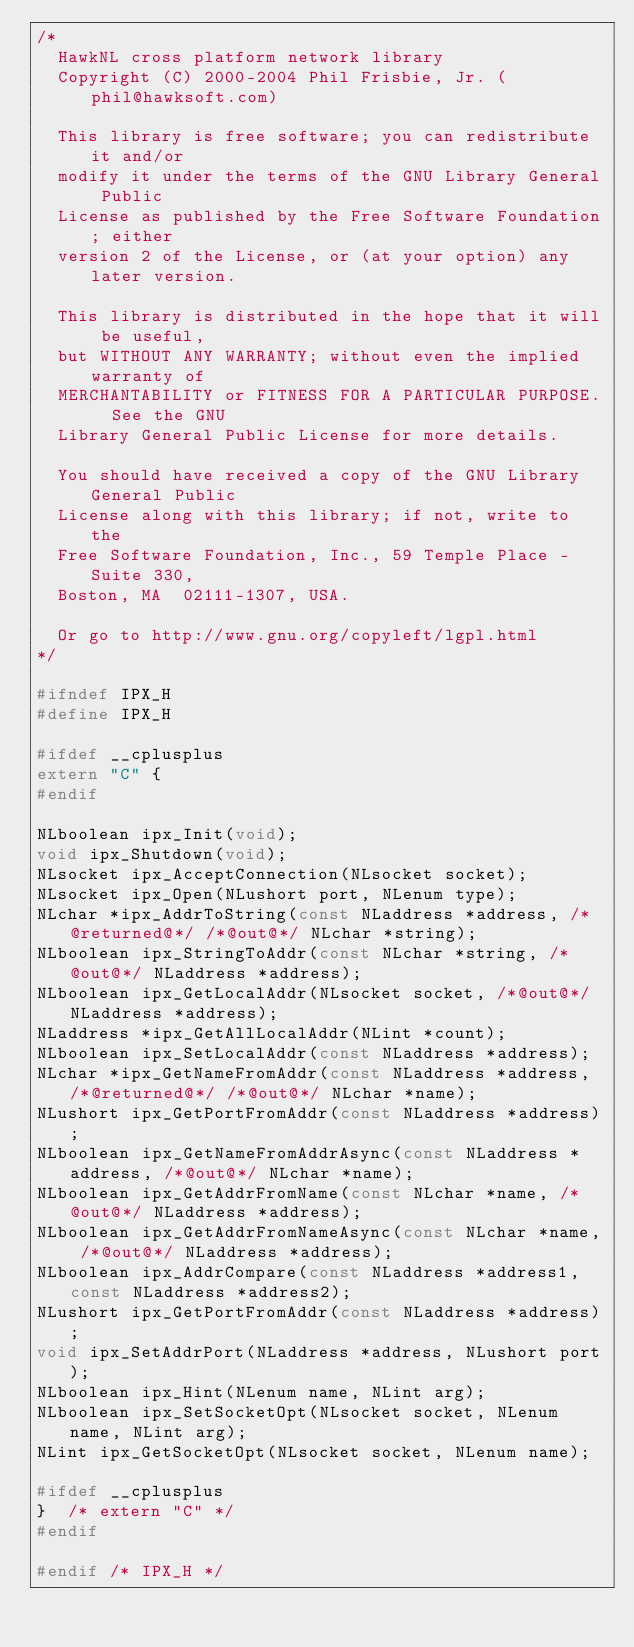Convert code to text. <code><loc_0><loc_0><loc_500><loc_500><_C_>/*
  HawkNL cross platform network library
  Copyright (C) 2000-2004 Phil Frisbie, Jr. (phil@hawksoft.com)

  This library is free software; you can redistribute it and/or
  modify it under the terms of the GNU Library General Public
  License as published by the Free Software Foundation; either
  version 2 of the License, or (at your option) any later version.

  This library is distributed in the hope that it will be useful,
  but WITHOUT ANY WARRANTY; without even the implied warranty of
  MERCHANTABILITY or FITNESS FOR A PARTICULAR PURPOSE.  See the GNU
  Library General Public License for more details.

  You should have received a copy of the GNU Library General Public
  License along with this library; if not, write to the
  Free Software Foundation, Inc., 59 Temple Place - Suite 330,
  Boston, MA  02111-1307, USA.

  Or go to http://www.gnu.org/copyleft/lgpl.html
*/

#ifndef IPX_H
#define IPX_H

#ifdef __cplusplus
extern "C" {
#endif

NLboolean ipx_Init(void);
void ipx_Shutdown(void);
NLsocket ipx_AcceptConnection(NLsocket socket);
NLsocket ipx_Open(NLushort port, NLenum type);
NLchar *ipx_AddrToString(const NLaddress *address, /*@returned@*/ /*@out@*/ NLchar *string);
NLboolean ipx_StringToAddr(const NLchar *string, /*@out@*/ NLaddress *address);
NLboolean ipx_GetLocalAddr(NLsocket socket, /*@out@*/ NLaddress *address);
NLaddress *ipx_GetAllLocalAddr(NLint *count);
NLboolean ipx_SetLocalAddr(const NLaddress *address);
NLchar *ipx_GetNameFromAddr(const NLaddress *address, /*@returned@*/ /*@out@*/ NLchar *name);
NLushort ipx_GetPortFromAddr(const NLaddress *address);
NLboolean ipx_GetNameFromAddrAsync(const NLaddress *address, /*@out@*/ NLchar *name);
NLboolean ipx_GetAddrFromName(const NLchar *name, /*@out@*/ NLaddress *address);
NLboolean ipx_GetAddrFromNameAsync(const NLchar *name, /*@out@*/ NLaddress *address);
NLboolean ipx_AddrCompare(const NLaddress *address1, const NLaddress *address2);
NLushort ipx_GetPortFromAddr(const NLaddress *address);
void ipx_SetAddrPort(NLaddress *address, NLushort port);
NLboolean ipx_Hint(NLenum name, NLint arg);
NLboolean ipx_SetSocketOpt(NLsocket socket, NLenum name, NLint arg);
NLint ipx_GetSocketOpt(NLsocket socket, NLenum name);

#ifdef __cplusplus
}  /* extern "C" */
#endif

#endif /* IPX_H */

</code> 